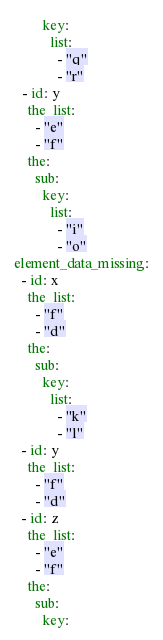Convert code to text. <code><loc_0><loc_0><loc_500><loc_500><_YAML_>        key:
          list:
            - "q"
            - "r"
  - id: y
    the_list:
      - "e"
      - "f"
    the:
      sub:
        key:
          list:
            - "i"
            - "o"
element_data_missing:
  - id: x
    the_list:
      - "f"
      - "d"
    the:
      sub:
        key:
          list:
            - "k"
            - "l"
  - id: y
    the_list:
      - "f"
      - "d"
  - id: z
    the_list:
      - "e"
      - "f"
    the:
      sub:
        key:
</code> 